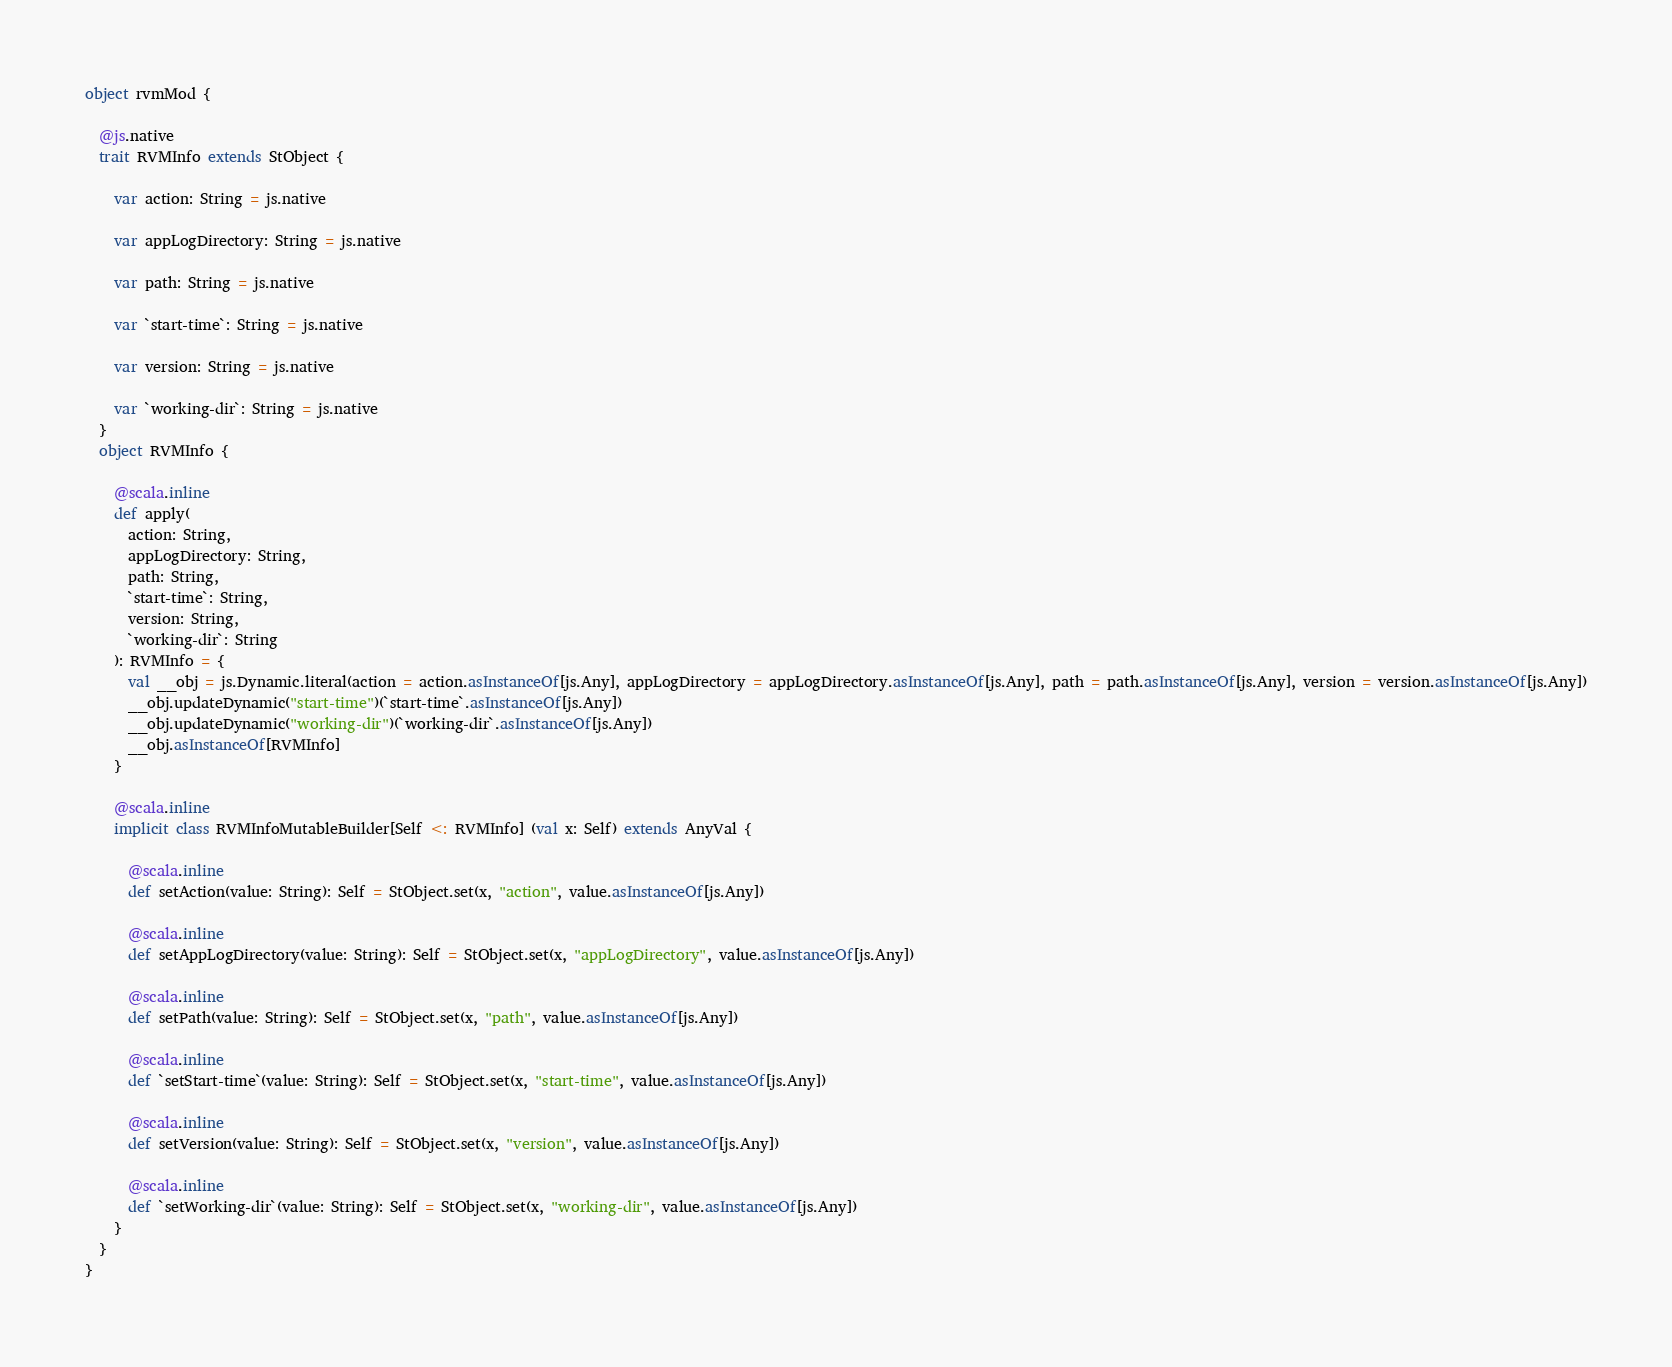Convert code to text. <code><loc_0><loc_0><loc_500><loc_500><_Scala_>object rvmMod {
  
  @js.native
  trait RVMInfo extends StObject {
    
    var action: String = js.native
    
    var appLogDirectory: String = js.native
    
    var path: String = js.native
    
    var `start-time`: String = js.native
    
    var version: String = js.native
    
    var `working-dir`: String = js.native
  }
  object RVMInfo {
    
    @scala.inline
    def apply(
      action: String,
      appLogDirectory: String,
      path: String,
      `start-time`: String,
      version: String,
      `working-dir`: String
    ): RVMInfo = {
      val __obj = js.Dynamic.literal(action = action.asInstanceOf[js.Any], appLogDirectory = appLogDirectory.asInstanceOf[js.Any], path = path.asInstanceOf[js.Any], version = version.asInstanceOf[js.Any])
      __obj.updateDynamic("start-time")(`start-time`.asInstanceOf[js.Any])
      __obj.updateDynamic("working-dir")(`working-dir`.asInstanceOf[js.Any])
      __obj.asInstanceOf[RVMInfo]
    }
    
    @scala.inline
    implicit class RVMInfoMutableBuilder[Self <: RVMInfo] (val x: Self) extends AnyVal {
      
      @scala.inline
      def setAction(value: String): Self = StObject.set(x, "action", value.asInstanceOf[js.Any])
      
      @scala.inline
      def setAppLogDirectory(value: String): Self = StObject.set(x, "appLogDirectory", value.asInstanceOf[js.Any])
      
      @scala.inline
      def setPath(value: String): Self = StObject.set(x, "path", value.asInstanceOf[js.Any])
      
      @scala.inline
      def `setStart-time`(value: String): Self = StObject.set(x, "start-time", value.asInstanceOf[js.Any])
      
      @scala.inline
      def setVersion(value: String): Self = StObject.set(x, "version", value.asInstanceOf[js.Any])
      
      @scala.inline
      def `setWorking-dir`(value: String): Self = StObject.set(x, "working-dir", value.asInstanceOf[js.Any])
    }
  }
}
</code> 